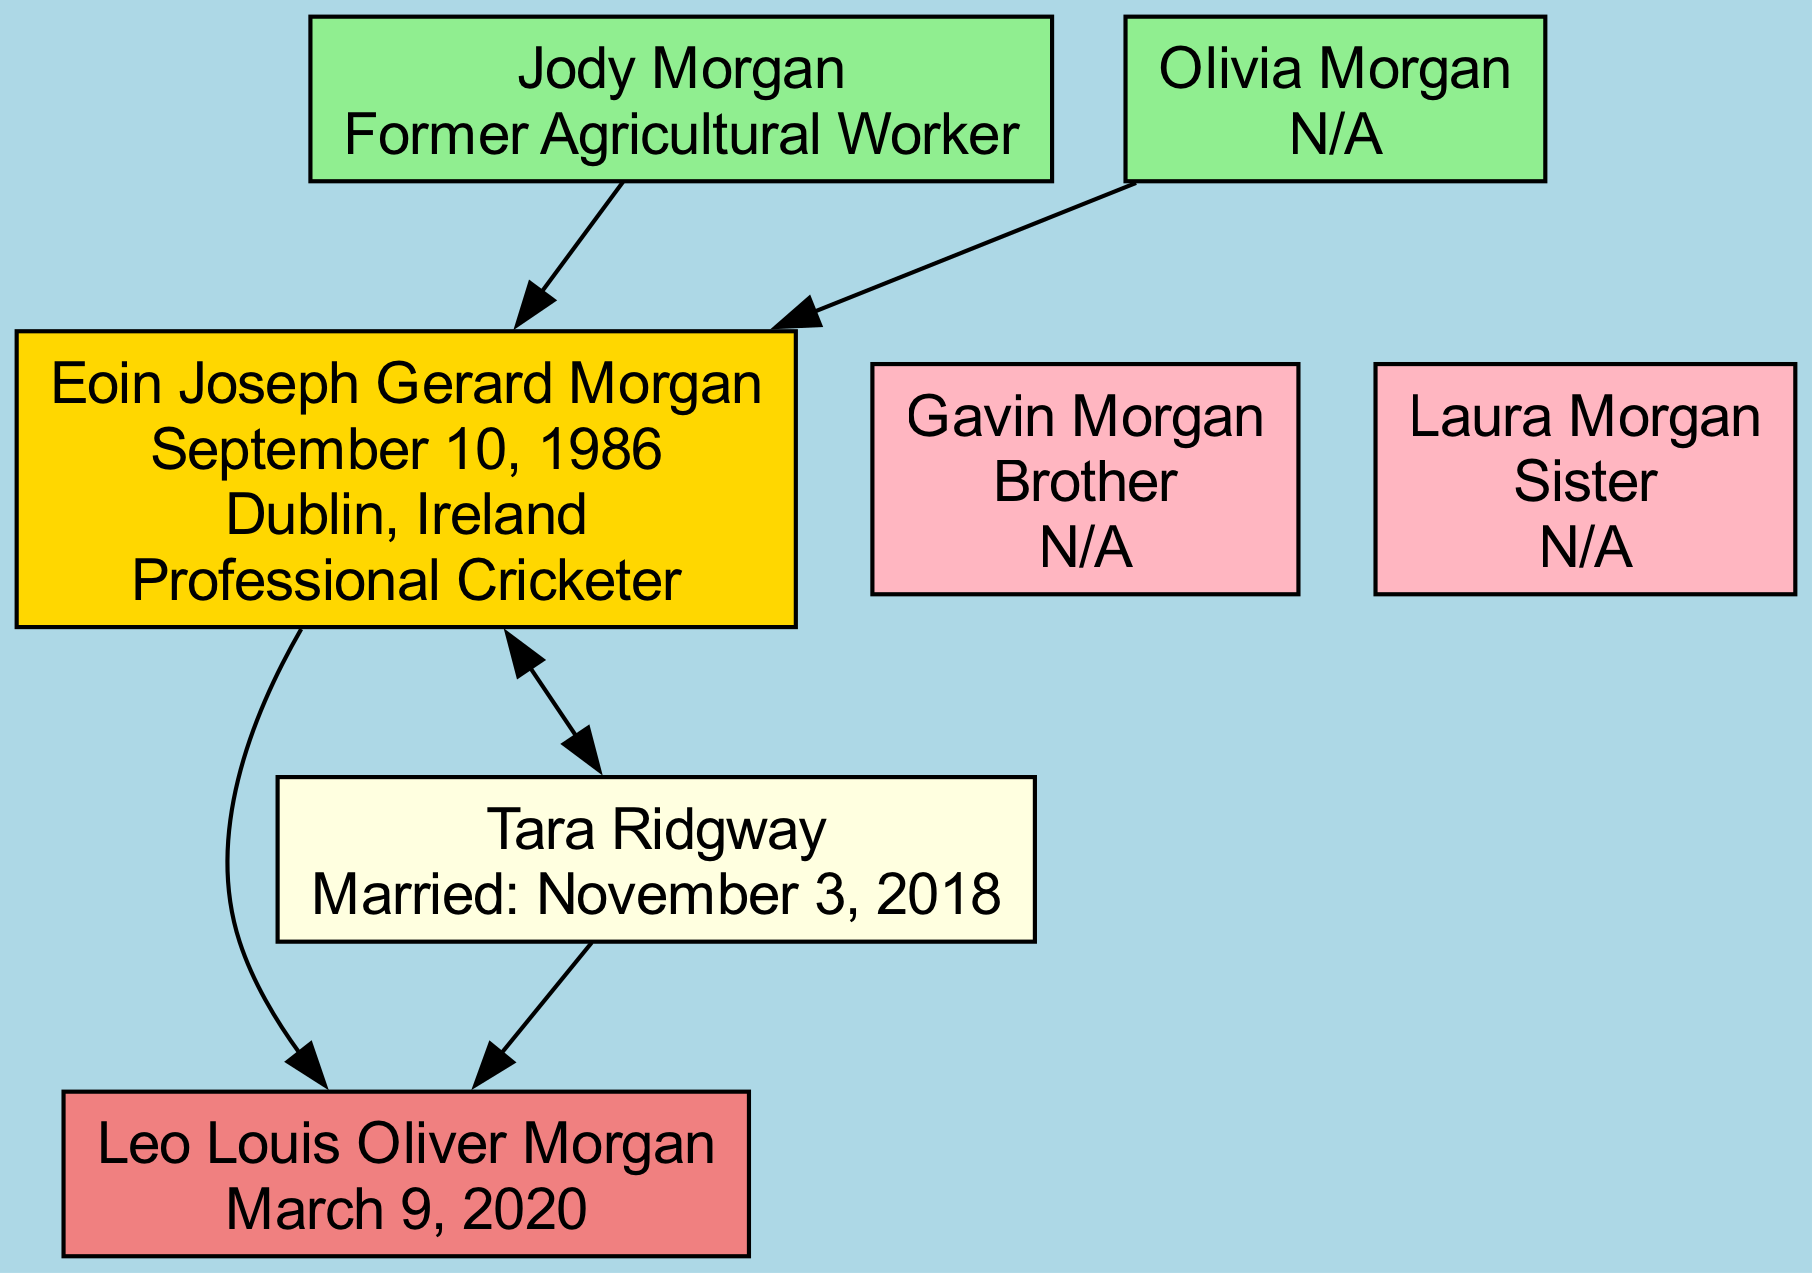What is Eoin Morgan's full name? The diagram shows that Eoin Morgan's full name is presented directly under his node as "Eoin Joseph Gerard Morgan."
Answer: Eoin Joseph Gerard Morgan Who are Eoin Morgan's parents? The parent nodes in the diagram display the names of Eoin's parents: his father is "Jody Morgan" and his mother is "Olivia Morgan."
Answer: Jody Morgan and Olivia Morgan How many siblings does Eoin Morgan have? By counting the sibling nodes connected to Eoin, there are two siblings: "Gavin Morgan" and "Laura Morgan."
Answer: Two What is the occupation of Eoin Morgan's father? In the diagram, the occupation listed for Eoin's father, Jody Morgan, is "Former Agricultural Worker."
Answer: Former Agricultural Worker What date did Eoin Morgan get married? The diagram indicates the marriage date under the spouse node, directly stating that Eoin Morgan married on "November 3, 2018."
Answer: November 3, 2018 What is the name of Eoin Morgan's child? The child node in the diagram specifies the name "Leo Louis Oliver Morgan" as Eoin's child.
Answer: Leo Louis Oliver Morgan Which sibling has no specified occupation? The nodes for Eoin's siblings indicate that both, "Gavin Morgan" and "Laura Morgan," are listed as "N/A" for occupation, but since only one was asked, the answer focuses on one.
Answer: Gavin Morgan Who is Eoin Morgan's spouse? The spouse node provides the name under which Eoin's partner is listed as "Tara Ridgway."
Answer: Tara Ridgway In which city was Eoin Morgan born? The birthplace listed in Eoin's node states that he was born in "Dublin, Ireland."
Answer: Dublin, Ireland 